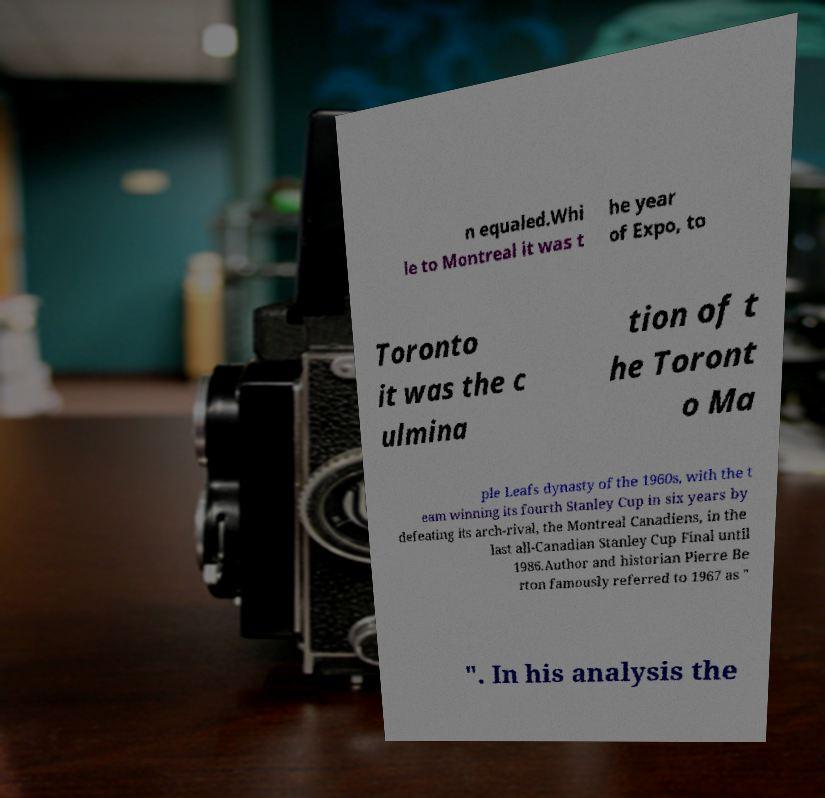Could you assist in decoding the text presented in this image and type it out clearly? n equaled.Whi le to Montreal it was t he year of Expo, to Toronto it was the c ulmina tion of t he Toront o Ma ple Leafs dynasty of the 1960s, with the t eam winning its fourth Stanley Cup in six years by defeating its arch-rival, the Montreal Canadiens, in the last all-Canadian Stanley Cup Final until 1986.Author and historian Pierre Be rton famously referred to 1967 as " ". In his analysis the 